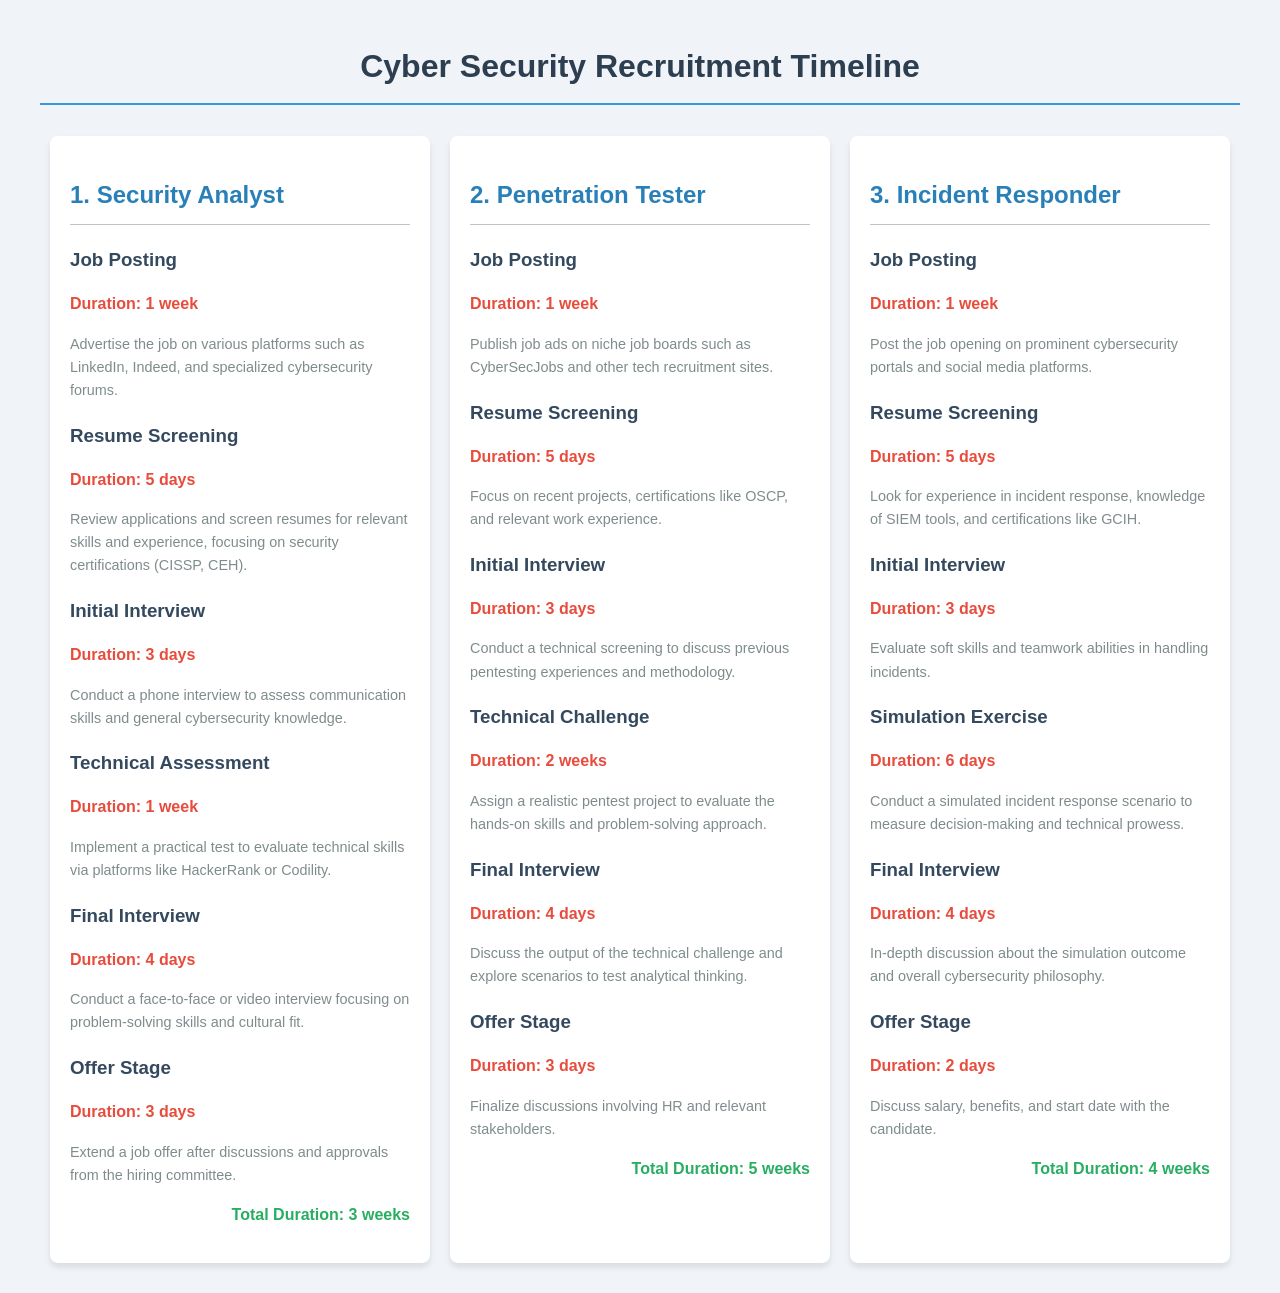What is the total duration for the Security Analyst role? The total duration is specified at the end of the section for the Security Analyst job role.
Answer: 3 weeks How long is the Technical Assessment stage for the Penetration Tester? The document provides the duration for each stage under the Penetration Tester role.
Answer: 2 weeks What are the job posting durations for all roles? Each role has the Job Posting stage listed, and the duration across each can be compared.
Answer: 1 week Which role has the shortest total duration? By comparing the total durations for each job role, it can be determined which one is shortest.
Answer: Security Analyst How many days does the Offer Stage take for the Incident Responder? The duration of this specific stage is included in the Incident Responder section of the document.
Answer: 2 days What specific certification is highlighted in the resume screening for Security Analyst? The document mentions important certifications to look for during the resume screening for this role.
Answer: CISSP, CEH What stage comes after the Initial Interview for the Penetration Tester? This requires knowledge of the sequence of stages listed for the Penetration Tester role.
Answer: Technical Challenge How many days is the Final Interview for the Incident Responder? The document provides details about the duration and content of the Final Interview for this specific role.
Answer: 4 days Which job role requires a Simulation Exercise? This information can be found by reviewing each job role's assessment stages.
Answer: Incident Responder 